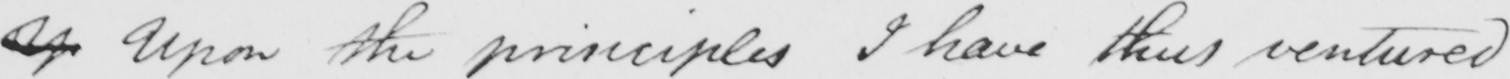Can you tell me what this handwritten text says? Up Upon the principles I have thus ventured 